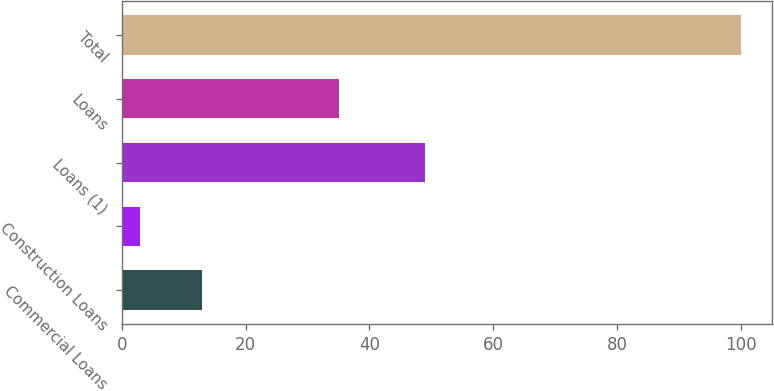Convert chart. <chart><loc_0><loc_0><loc_500><loc_500><bar_chart><fcel>Commercial Loans<fcel>Construction Loans<fcel>Loans (1)<fcel>Loans<fcel>Total<nl><fcel>13<fcel>3<fcel>49<fcel>35<fcel>100<nl></chart> 